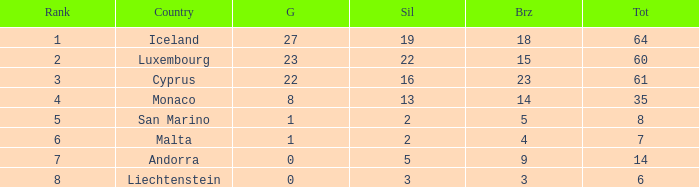How many bronzes for Iceland with over 2 silvers? 18.0. 